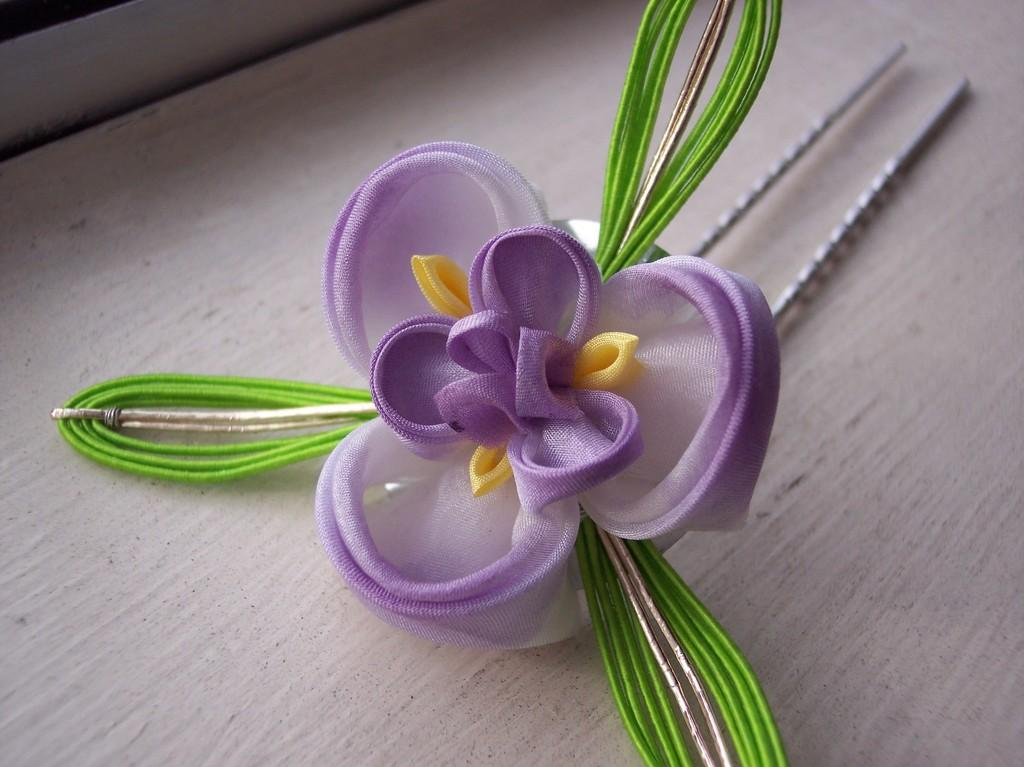What type of object is in the image? There is a fabric flower in the image. What colors can be seen on the fabric flower? The fabric flower has violet and green colors. Where is the fabric flower placed in the image? The fabric flower is placed on a plain surface. How many boats are visible in the image? There are no boats present in the image; it features a fabric flower on a plain surface. What type of oil can be seen dripping from the fabric flower? There is no oil present in the image; it only shows a fabric flower with violet and green colors on a plain surface. 